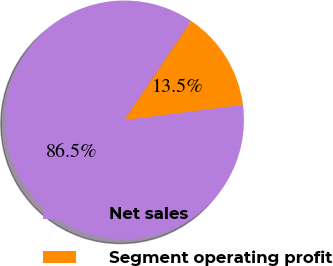Convert chart. <chart><loc_0><loc_0><loc_500><loc_500><pie_chart><fcel>Net sales<fcel>Segment operating profit<nl><fcel>86.48%<fcel>13.52%<nl></chart> 